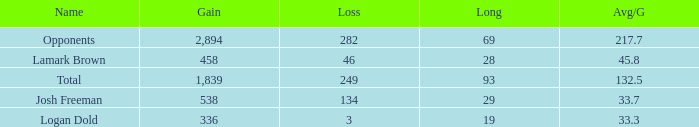How much Gain has a Long of 29, and an Avg/G smaller than 33.7? 0.0. 